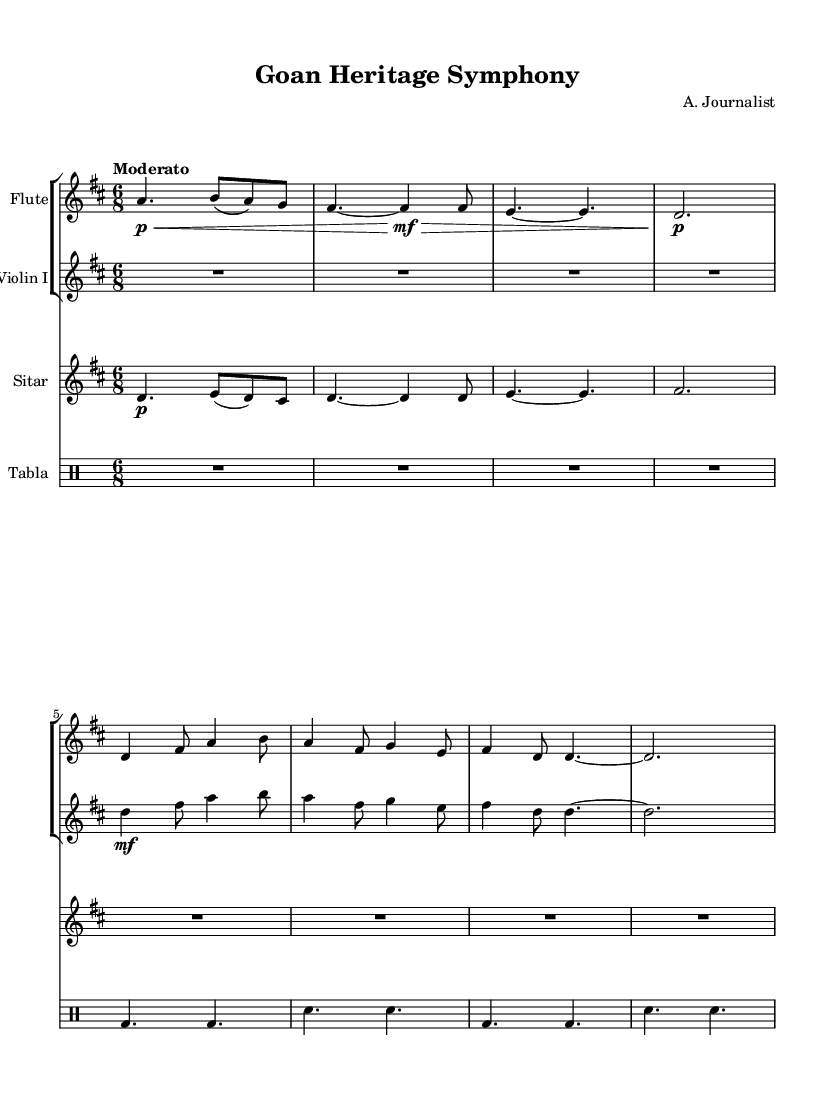What is the key signature of this music? The key signature is D major, identified by two sharps in the signature at the beginning of the staff.
Answer: D major What is the time signature of this piece? The time signature is 6/8, indicated at the beginning of the music with a fraction.
Answer: 6/8 What is the tempo marking of the symphony? The tempo marking is "Moderato", which suggests a moderately paced tempo, found towards the top of the sheet music.
Answer: Moderato Which instruments are used in this symphony? The instruments used are Flute, Violin I, Sitar, and Tabla, noted at the start of each staff and drum staff.
Answer: Flute, Violin I, Sitar, Tabla What type of rhythm does the Tabla play in Theme B? The Tabla plays a simple alternating rhythm, characterized by a consistent pattern of bass and snare. This can be seen from the notation below the staves.
Answer: Alternating bass and snare rhythm How many measures are there in the introduction section? There are a total of four measures in the introduction section for the Flute, Violin I, Sitar, and Tabla, as seen in the first part of the music before Theme A begins.
Answer: 4 measures What is the relationship of the Sitar's theme in comparison to the Flute's theme? The Sitar theme begins with a similar melodic line but modifies it rhythmically; this suggests a fusion of melodies which reflects the cultural blend in Goan music.
Answer: Similar rhythmic modification 